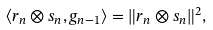Convert formula to latex. <formula><loc_0><loc_0><loc_500><loc_500>\langle r _ { n } \otimes s _ { n } , g _ { n - 1 } \rangle = \| r _ { n } \otimes s _ { n } \| ^ { 2 } ,</formula> 